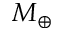<formula> <loc_0><loc_0><loc_500><loc_500>M _ { \oplus }</formula> 